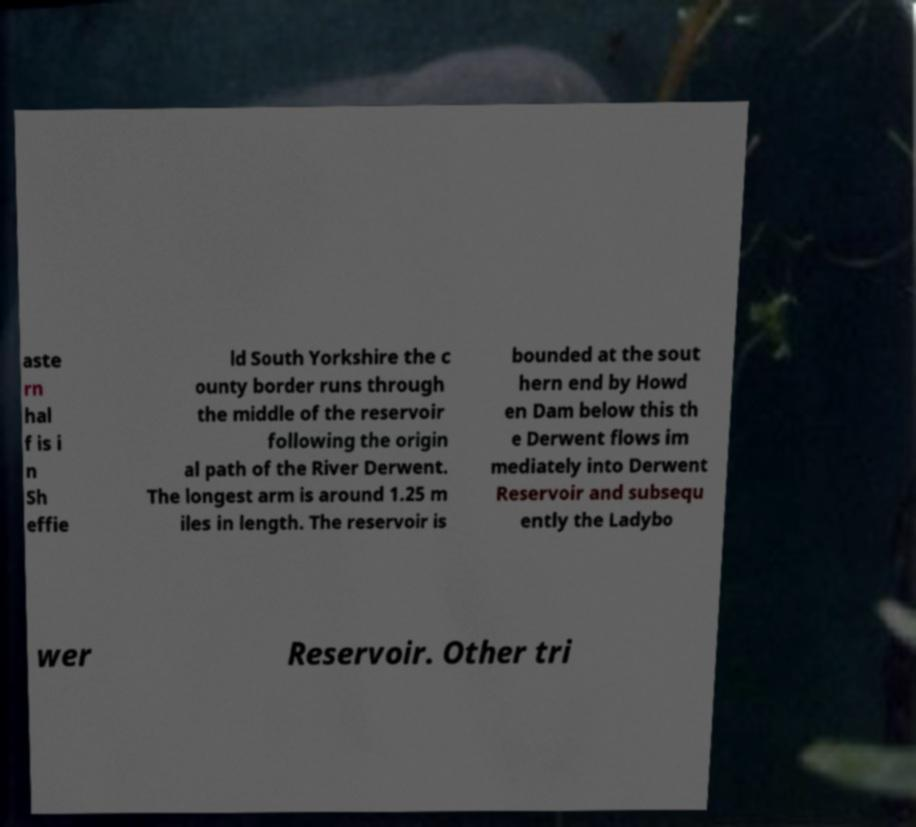Can you read and provide the text displayed in the image?This photo seems to have some interesting text. Can you extract and type it out for me? aste rn hal f is i n Sh effie ld South Yorkshire the c ounty border runs through the middle of the reservoir following the origin al path of the River Derwent. The longest arm is around 1.25 m iles in length. The reservoir is bounded at the sout hern end by Howd en Dam below this th e Derwent flows im mediately into Derwent Reservoir and subsequ ently the Ladybo wer Reservoir. Other tri 